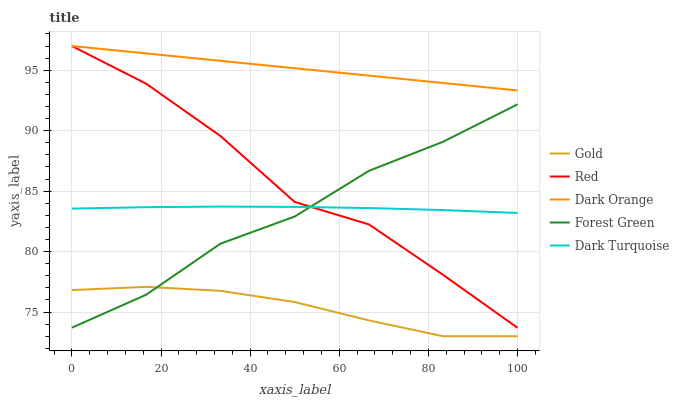Does Gold have the minimum area under the curve?
Answer yes or no. Yes. Does Dark Orange have the maximum area under the curve?
Answer yes or no. Yes. Does Forest Green have the minimum area under the curve?
Answer yes or no. No. Does Forest Green have the maximum area under the curve?
Answer yes or no. No. Is Dark Orange the smoothest?
Answer yes or no. Yes. Is Red the roughest?
Answer yes or no. Yes. Is Forest Green the smoothest?
Answer yes or no. No. Is Forest Green the roughest?
Answer yes or no. No. Does Gold have the lowest value?
Answer yes or no. Yes. Does Forest Green have the lowest value?
Answer yes or no. No. Does Red have the highest value?
Answer yes or no. Yes. Does Forest Green have the highest value?
Answer yes or no. No. Is Gold less than Dark Turquoise?
Answer yes or no. Yes. Is Dark Orange greater than Dark Turquoise?
Answer yes or no. Yes. Does Forest Green intersect Gold?
Answer yes or no. Yes. Is Forest Green less than Gold?
Answer yes or no. No. Is Forest Green greater than Gold?
Answer yes or no. No. Does Gold intersect Dark Turquoise?
Answer yes or no. No. 